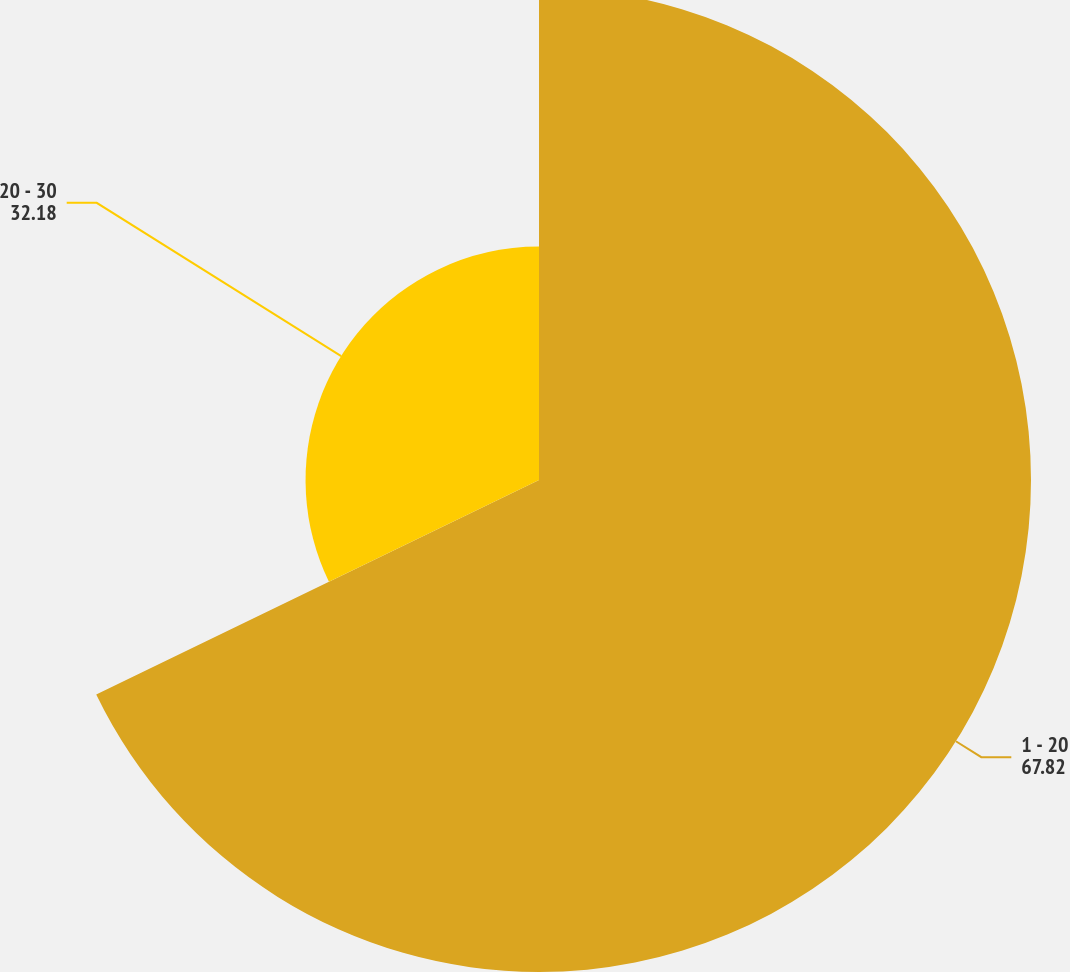<chart> <loc_0><loc_0><loc_500><loc_500><pie_chart><fcel>1 - 20<fcel>20 - 30<nl><fcel>67.82%<fcel>32.18%<nl></chart> 